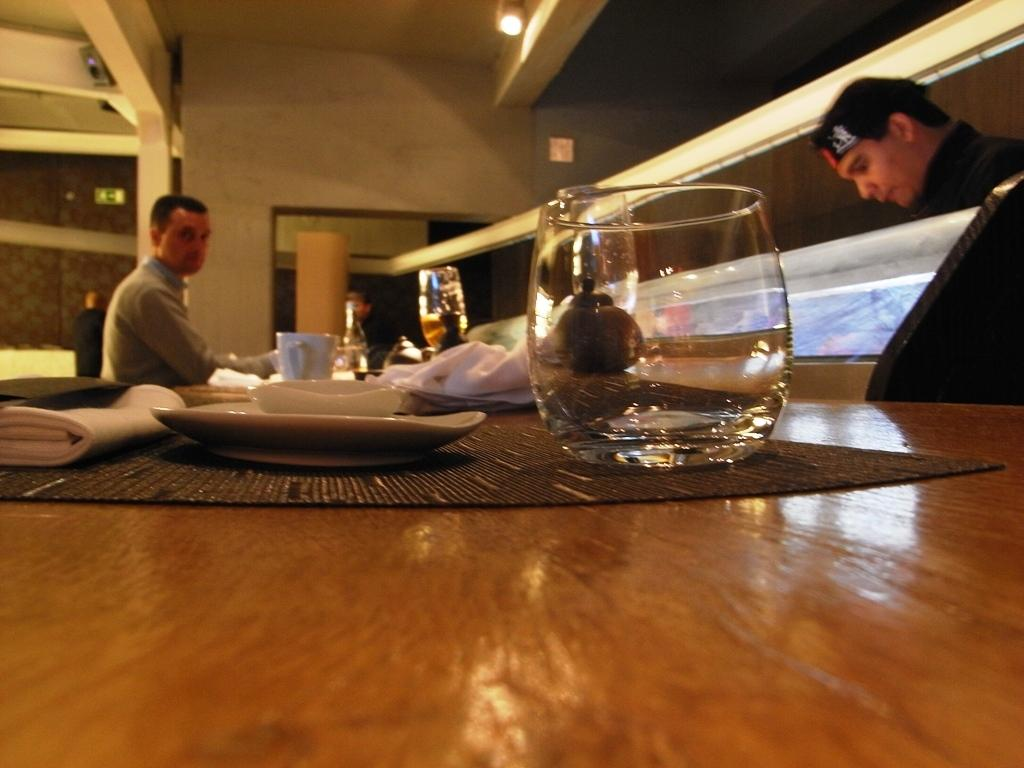What type of setting is depicted in the image? The image is an indoor scene. What can be seen attached to the roof in the image? There is a light attached to the roof. How many people are present in the image? Two people are standing in the image. Can you describe the clothing of one of the men? One of the men is wearing a black cap. What furniture is present in the image? There is a table in the image. What items can be seen on the table? On the table, there is a mat, a cup, a mug, and a glass. What type of floor can be seen in the image? The image is an indoor scene, but there is no information about the floor in the provided facts. Does the existence of the table in the image prove the existence of the universe? The presence of a table in the image does not prove the existence of the universe, as the two are unrelated. 